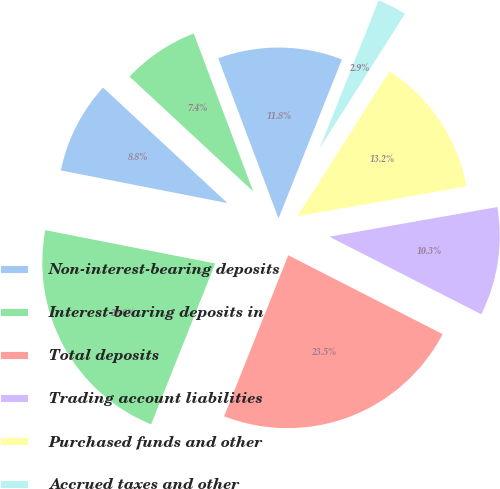Convert chart. <chart><loc_0><loc_0><loc_500><loc_500><pie_chart><fcel>Non-interest-bearing deposits<fcel>Interest-bearing deposits in<fcel>Total deposits<fcel>Trading account liabilities<fcel>Purchased funds and other<fcel>Accrued taxes and other<fcel>Long-term debt and<fcel>Other liabilities<nl><fcel>8.83%<fcel>22.05%<fcel>23.52%<fcel>10.3%<fcel>13.23%<fcel>2.95%<fcel>11.77%<fcel>7.36%<nl></chart> 